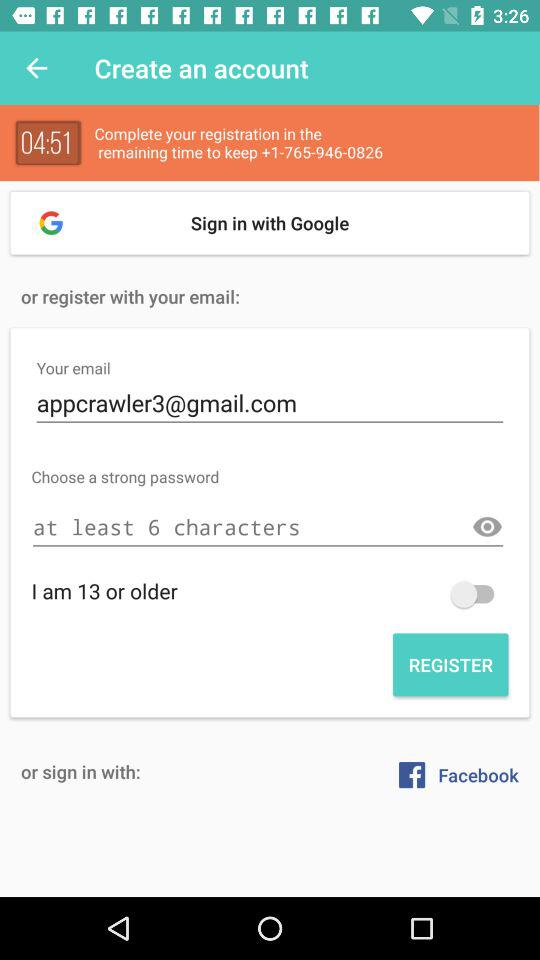What is the remaining time to complete the registration? The remaining time is 4 minutes and 51 seconds. 